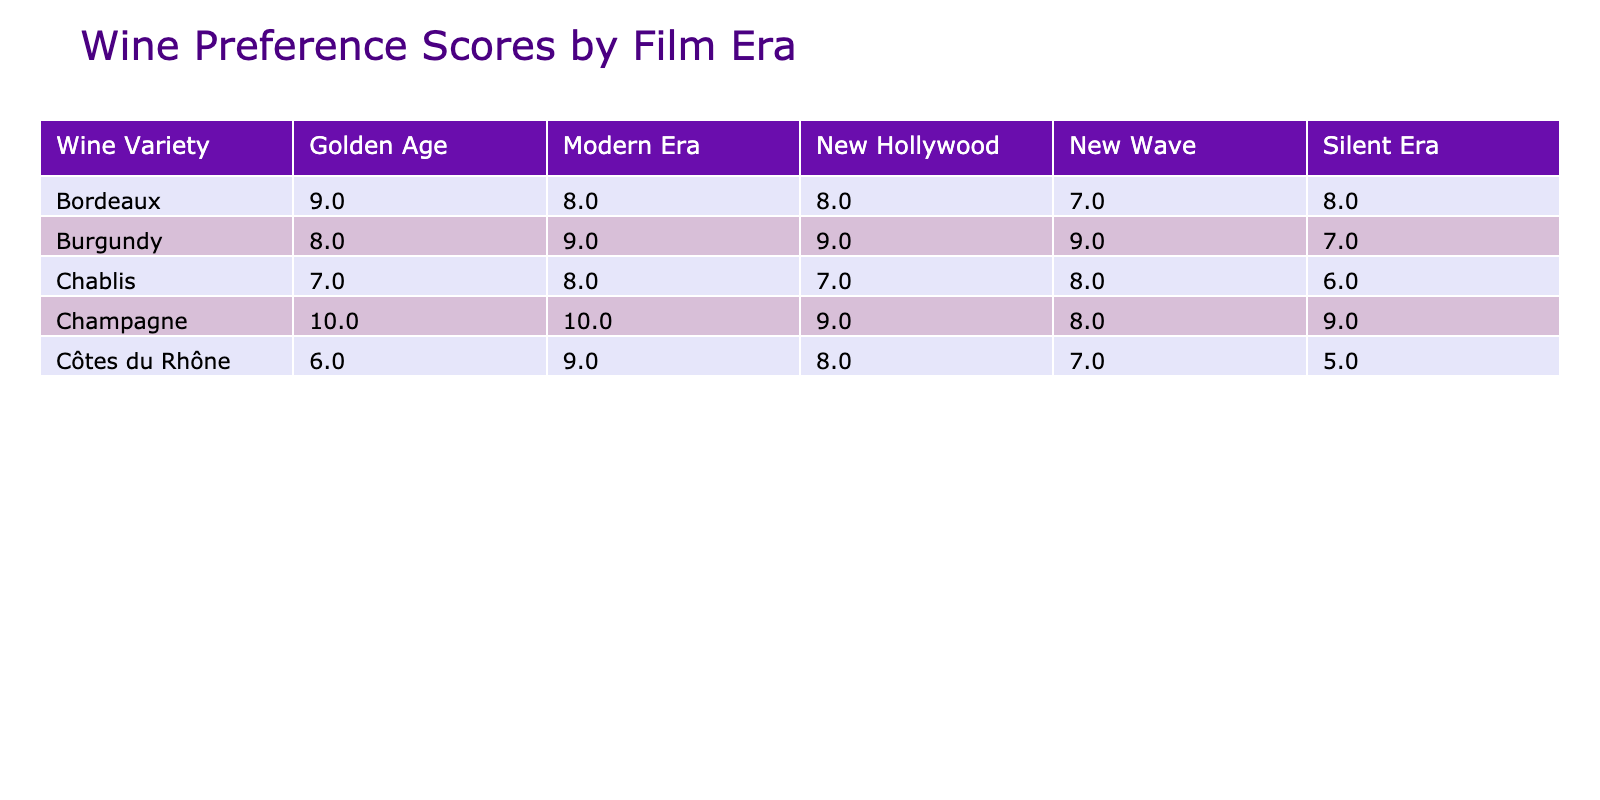What wine variety has the highest customer preference score in the Silent Era? Looking at the Silent Era column, the highest score is 9, which corresponds to Champagne.
Answer: Champagne What is the customer preference score for Bordeaux in the Golden Age? According to the table, Bordeaux has a customer preference score of 9 during the Golden Age.
Answer: 9 Which film era had the highest average customer preference score across all wine varieties? To find this, we'll calculate the average scores for each era. Silent Era: (8+7+9+6+5)/5 = 7.00, Golden Age: (9+8+10+7+6)/5 = 8.00, New Wave: (7+9+8+8+7)/5 = 7.80, New Hollywood: (8+9+9+7+8)/5 = 8.20, Modern Era: (8+9+10+8+9)/5 = 8.80. The highest average is for the Modern Era at 8.80.
Answer: Modern Era Is it true that Chablis has a higher customer preference score in the New Hollywood era compared to the Golden Age? In the New Hollywood era, Chablis scores 7, while in the Golden Age, it scores 7 as well. Therefore, Chablis does not have a higher score in New Hollywood compared to Golden Age.
Answer: No What is the total sales volume for Champagne across all film eras? Summing up Champagne's sales volumes: 150 (Silent) + 200 (Golden Age) + 160 (New Wave) + 190 (New Hollywood) + 220 (Modern Era) = 1120.
Answer: 1120 How does the average price of Burgundy in the New Wave era compare to its average price in the Modern Era? The average price of Burgundy in the New Wave era is 105, while in the Modern Era, it's 115. Hence, Burgundy is more expensive in the Modern Era compared to the New Wave.
Answer: More expensive Which wine variety has the most consistent customer preference scores across the Film Eras? By examining the scores, Côtes du Rhône has scores of 5, 6, 7, 8, and 9 across the film eras. The variation is 4. In contrast, other varieties show greater disparity. Therefore, Côtes du Rhône is the most consistent.
Answer: Côtes du Rhône What is the difference in customer preference score between Bordeaux in the Modern Era and Burgundy in the same era? Bordeaux scores 8 and Burgundy scores 9 in the Modern Era. The difference is 9 - 8 = 1.
Answer: 1 In which era did Chardonnay receive its highest preference score? Chardonnay is not listed in the data provided; thus, it does not have a score in any era.
Answer: Not applicable 